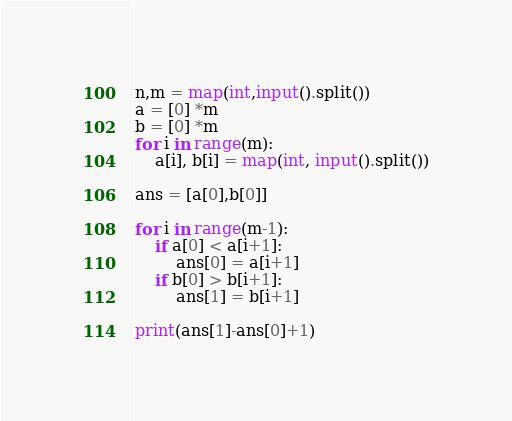<code> <loc_0><loc_0><loc_500><loc_500><_Python_>n,m = map(int,input().split())
a = [0] *m
b = [0] *m
for i in range(m):
    a[i], b[i] = map(int, input().split())

ans = [a[0],b[0]]

for i in range(m-1):
    if a[0] < a[i+1]:
        ans[0] = a[i+1]
    if b[0] > b[i+1]:
        ans[1] = b[i+1]

print(ans[1]-ans[0]+1)
</code> 